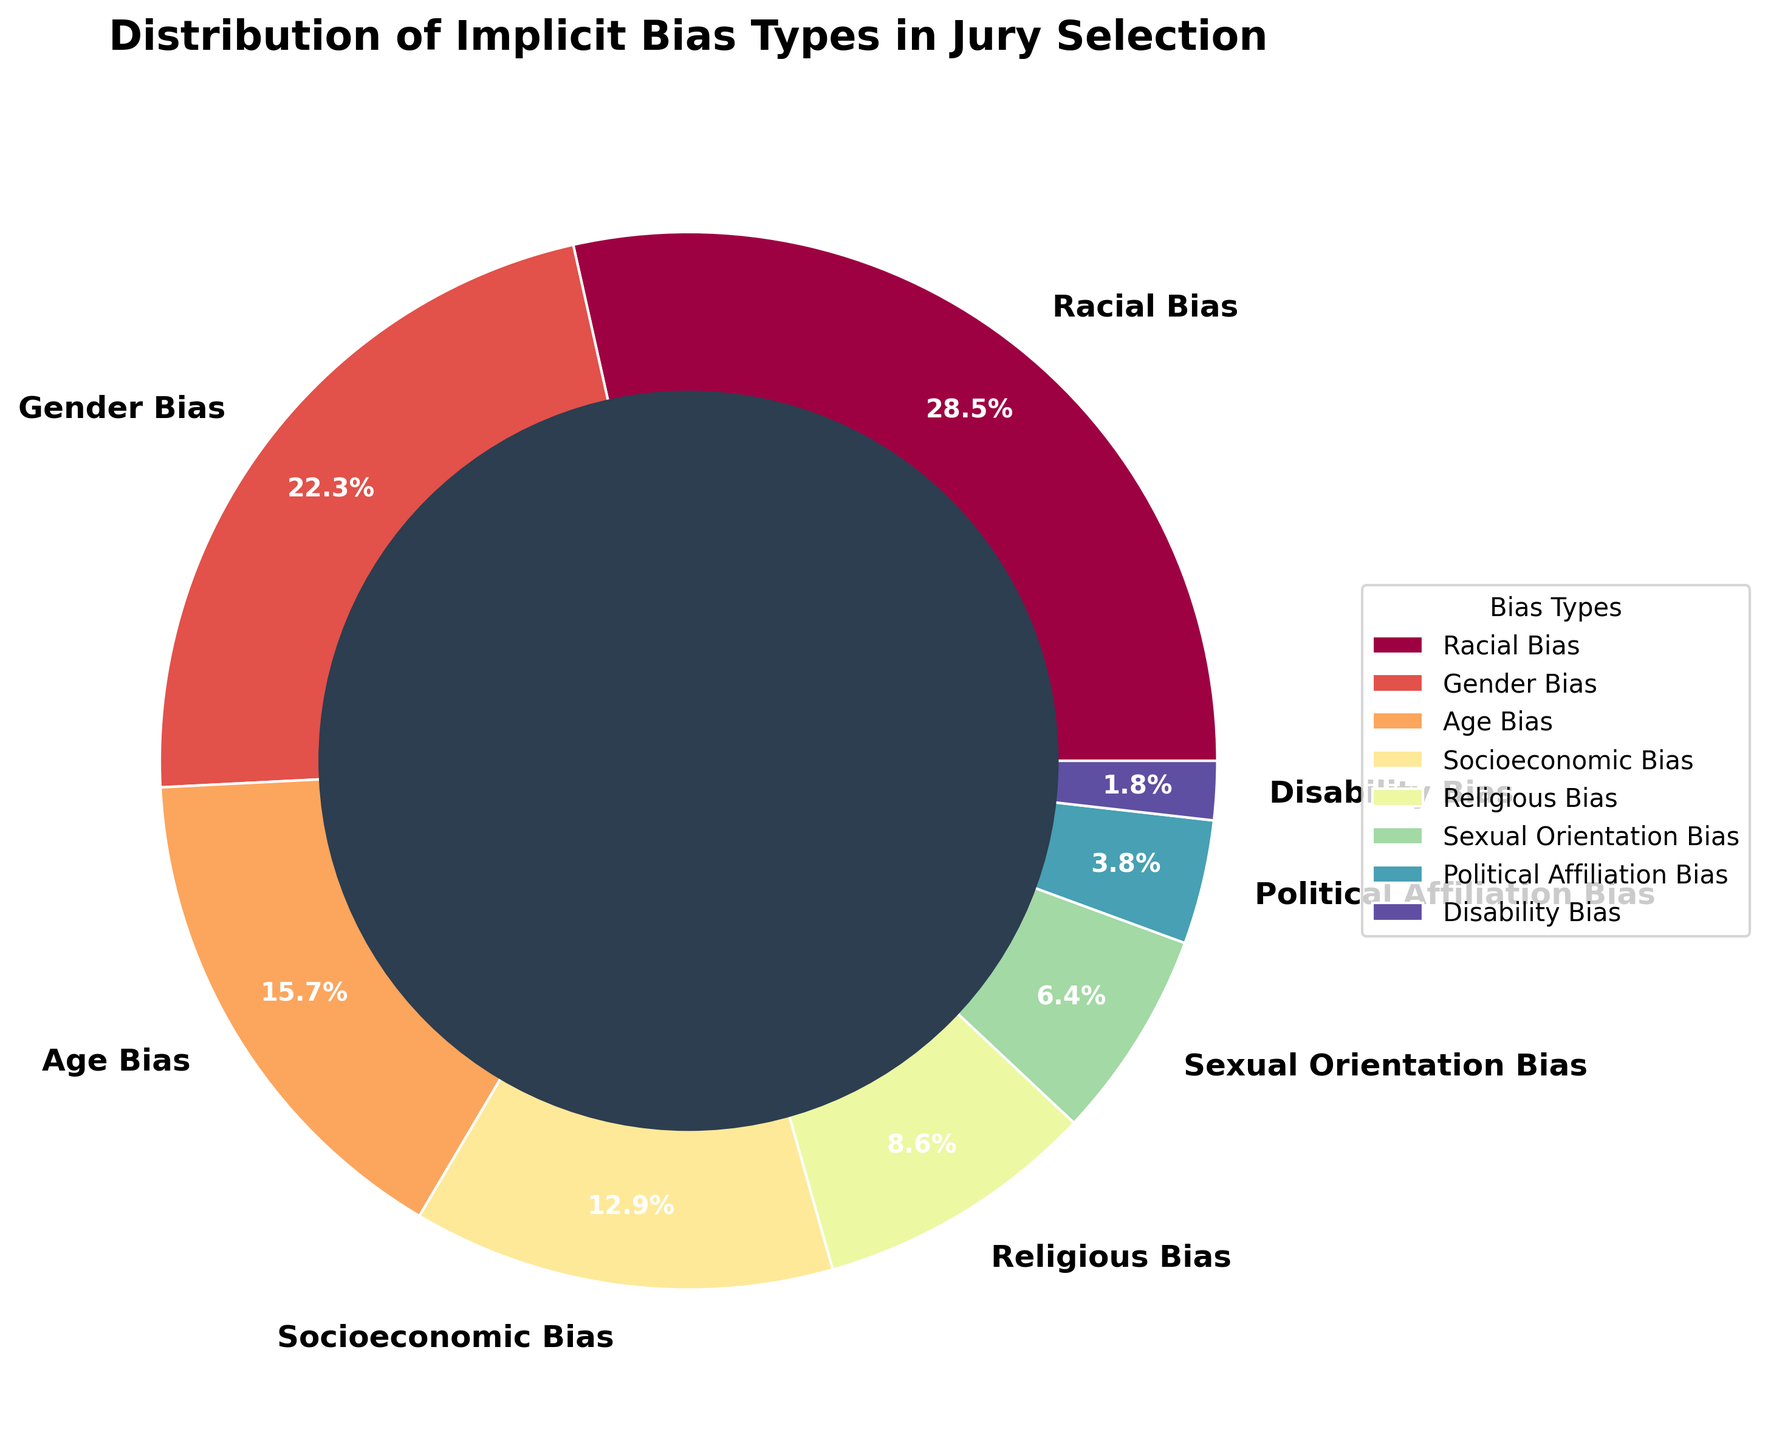Which bias type is the most prevalent in the jury selection process? The pie chart shows various bias types, with the largest section representing the most prevalent bias. Racial Bias has the highest percentage at 28.5%.
Answer: Racial Bias Which bias type has the smallest percentage? The pie chart indicates different bias types, and the smallest section corresponds to Disability Bias at 1.8%.
Answer: Disability Bias How much larger is the percentage of Racial Bias compared to Sexual Orientation Bias? The percentage of Racial Bias is 28.5%, and the percentage of Sexual Orientation Bias is 6.4%. The difference is 28.5% - 6.4% = 22.1%.
Answer: 22.1% What is the combined percentage of Socioeconomic Bias and Religious Bias? The percentages of Socioeconomic Bias and Religious Bias are 12.9% and 8.6%, respectively. The combined percentage is 12.9% + 8.6% = 21.5%.
Answer: 21.5% Among the bias types visualized, which two biases are the closest in terms of percentage? The pie chart shows the percentages for various bias types. Socioeconomic Bias at 12.9% and Age Bias at 15.7% have the smallest difference in percentage (15.7% - 12.9% = 2.8%).
Answer: Age Bias and Socioeconomic Bias Is Gender Bias more than double the percentage of Political Affiliation Bias? Gender Bias is 22.3%, and Political Affiliation Bias is 3.8%. Double the Political Affiliation Bias would be 2 * 3.8% = 7.6%, which is much less than Gender Bias's 22.3%, confirming it's more than double.
Answer: Yes Which bias has a larger percentage: Age Bias or Gender Bias? The pie chart indicates Age Bias at 15.7% and Gender Bias at 22.3%. Comparison shows that 22.3% (Gender Bias) is greater than 15.7% (Age Bias).
Answer: Gender Bias What are the three least common bias types in jury selection? Looking at the pie chart, the three bias types with the smallest percentages are Disability Bias (1.8%), Political Affiliation Bias (3.8%), and Sexual Orientation Bias (6.4%).
Answer: Disability Bias, Political Affiliation Bias, and Sexual Orientation Bias How much larger is the total percentage of the top three bias types compared to the total percentage of the bottom three bias types? The top three biases are Racial Bias (28.5%), Gender Bias (22.3%), and Age Bias (15.7%), summing to 66.5%. The bottom three are Disability Bias (1.8%), Political Affiliation Bias (3.8%), and Sexual Orientation Bias (6.4%), totaling 12%. The difference is 66.5% - 12% = 54.5%.
Answer: 54.5% Which wedge on the pie chart is colored using the darkest hue? The pie chart uses a color palette where darker hues often represent smaller percentages. Disability Bias has the darkest hue as it is the smallest percentage (1.8%).
Answer: Disability Bias 